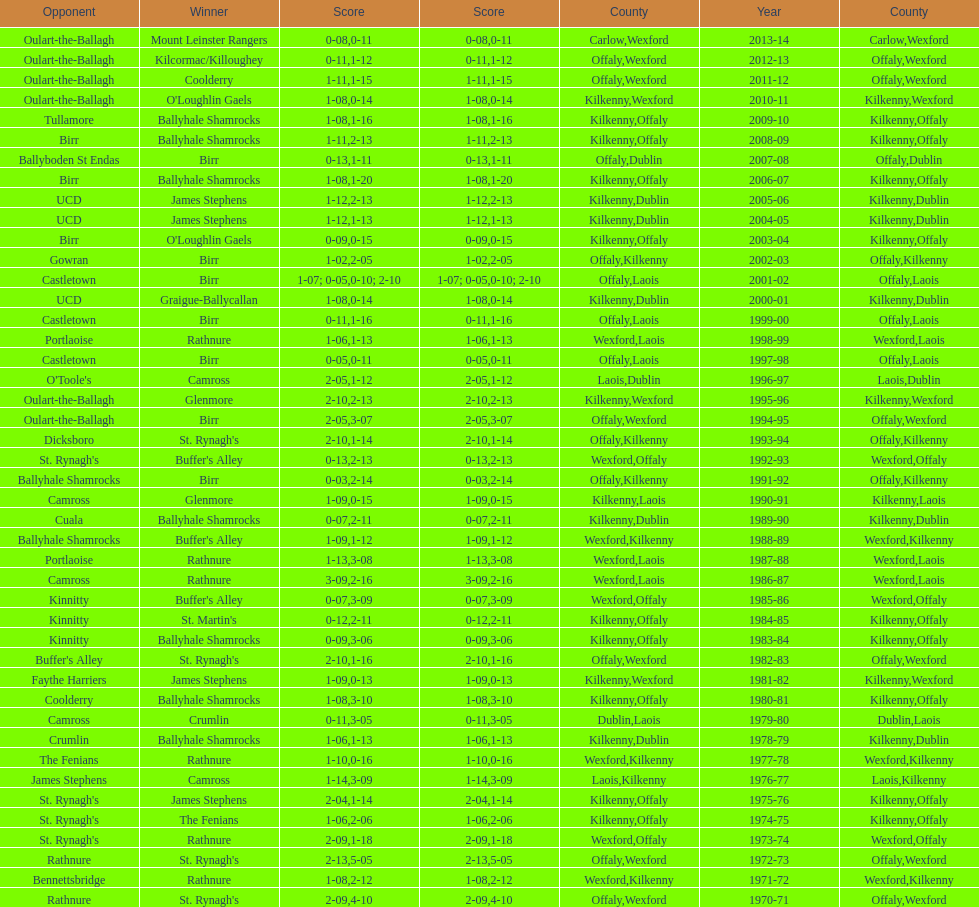How many consecutive years did rathnure win? 2. Can you parse all the data within this table? {'header': ['Opponent', 'Winner', 'Score', 'Score', 'County', 'Year', 'County'], 'rows': [['Oulart-the-Ballagh', 'Mount Leinster Rangers', '0-08', '0-11', 'Carlow', '2013-14', 'Wexford'], ['Oulart-the-Ballagh', 'Kilcormac/Killoughey', '0-11', '1-12', 'Offaly', '2012-13', 'Wexford'], ['Oulart-the-Ballagh', 'Coolderry', '1-11', '1-15', 'Offaly', '2011-12', 'Wexford'], ['Oulart-the-Ballagh', "O'Loughlin Gaels", '1-08', '0-14', 'Kilkenny', '2010-11', 'Wexford'], ['Tullamore', 'Ballyhale Shamrocks', '1-08', '1-16', 'Kilkenny', '2009-10', 'Offaly'], ['Birr', 'Ballyhale Shamrocks', '1-11', '2-13', 'Kilkenny', '2008-09', 'Offaly'], ['Ballyboden St Endas', 'Birr', '0-13', '1-11', 'Offaly', '2007-08', 'Dublin'], ['Birr', 'Ballyhale Shamrocks', '1-08', '1-20', 'Kilkenny', '2006-07', 'Offaly'], ['UCD', 'James Stephens', '1-12', '2-13', 'Kilkenny', '2005-06', 'Dublin'], ['UCD', 'James Stephens', '1-12', '1-13', 'Kilkenny', '2004-05', 'Dublin'], ['Birr', "O'Loughlin Gaels", '0-09', '0-15', 'Kilkenny', '2003-04', 'Offaly'], ['Gowran', 'Birr', '1-02', '2-05', 'Offaly', '2002-03', 'Kilkenny'], ['Castletown', 'Birr', '1-07; 0-05', '0-10; 2-10', 'Offaly', '2001-02', 'Laois'], ['UCD', 'Graigue-Ballycallan', '1-08', '0-14', 'Kilkenny', '2000-01', 'Dublin'], ['Castletown', 'Birr', '0-11', '1-16', 'Offaly', '1999-00', 'Laois'], ['Portlaoise', 'Rathnure', '1-06', '1-13', 'Wexford', '1998-99', 'Laois'], ['Castletown', 'Birr', '0-05', '0-11', 'Offaly', '1997-98', 'Laois'], ["O'Toole's", 'Camross', '2-05', '1-12', 'Laois', '1996-97', 'Dublin'], ['Oulart-the-Ballagh', 'Glenmore', '2-10', '2-13', 'Kilkenny', '1995-96', 'Wexford'], ['Oulart-the-Ballagh', 'Birr', '2-05', '3-07', 'Offaly', '1994-95', 'Wexford'], ['Dicksboro', "St. Rynagh's", '2-10', '1-14', 'Offaly', '1993-94', 'Kilkenny'], ["St. Rynagh's", "Buffer's Alley", '0-13', '2-13', 'Wexford', '1992-93', 'Offaly'], ['Ballyhale Shamrocks', 'Birr', '0-03', '2-14', 'Offaly', '1991-92', 'Kilkenny'], ['Camross', 'Glenmore', '1-09', '0-15', 'Kilkenny', '1990-91', 'Laois'], ['Cuala', 'Ballyhale Shamrocks', '0-07', '2-11', 'Kilkenny', '1989-90', 'Dublin'], ['Ballyhale Shamrocks', "Buffer's Alley", '1-09', '1-12', 'Wexford', '1988-89', 'Kilkenny'], ['Portlaoise', 'Rathnure', '1-13', '3-08', 'Wexford', '1987-88', 'Laois'], ['Camross', 'Rathnure', '3-09', '2-16', 'Wexford', '1986-87', 'Laois'], ['Kinnitty', "Buffer's Alley", '0-07', '3-09', 'Wexford', '1985-86', 'Offaly'], ['Kinnitty', "St. Martin's", '0-12', '2-11', 'Kilkenny', '1984-85', 'Offaly'], ['Kinnitty', 'Ballyhale Shamrocks', '0-09', '3-06', 'Kilkenny', '1983-84', 'Offaly'], ["Buffer's Alley", "St. Rynagh's", '2-10', '1-16', 'Offaly', '1982-83', 'Wexford'], ['Faythe Harriers', 'James Stephens', '1-09', '0-13', 'Kilkenny', '1981-82', 'Wexford'], ['Coolderry', 'Ballyhale Shamrocks', '1-08', '3-10', 'Kilkenny', '1980-81', 'Offaly'], ['Camross', 'Crumlin', '0-11', '3-05', 'Dublin', '1979-80', 'Laois'], ['Crumlin', 'Ballyhale Shamrocks', '1-06', '1-13', 'Kilkenny', '1978-79', 'Dublin'], ['The Fenians', 'Rathnure', '1-10', '0-16', 'Wexford', '1977-78', 'Kilkenny'], ['James Stephens', 'Camross', '1-14', '3-09', 'Laois', '1976-77', 'Kilkenny'], ["St. Rynagh's", 'James Stephens', '2-04', '1-14', 'Kilkenny', '1975-76', 'Offaly'], ["St. Rynagh's", 'The Fenians', '1-06', '2-06', 'Kilkenny', '1974-75', 'Offaly'], ["St. Rynagh's", 'Rathnure', '2-09', '1-18', 'Wexford', '1973-74', 'Offaly'], ['Rathnure', "St. Rynagh's", '2-13', '5-05', 'Offaly', '1972-73', 'Wexford'], ['Bennettsbridge', 'Rathnure', '1-08', '2-12', 'Wexford', '1971-72', 'Kilkenny'], ['Rathnure', "St. Rynagh's", '2-09', '4-10', 'Offaly', '1970-71', 'Wexford']]} 